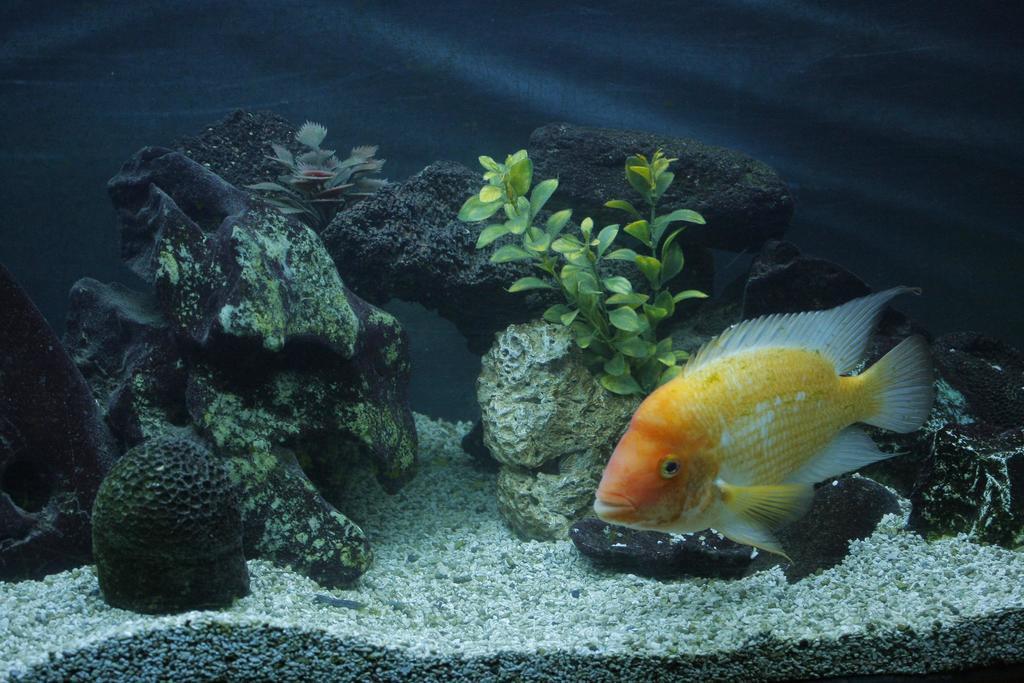In one or two sentences, can you explain what this image depicts? This picture is taken in an aquarium. At the bottom right, there is a fish which is in orange and white in color. Behind it, there are stones and plants. 